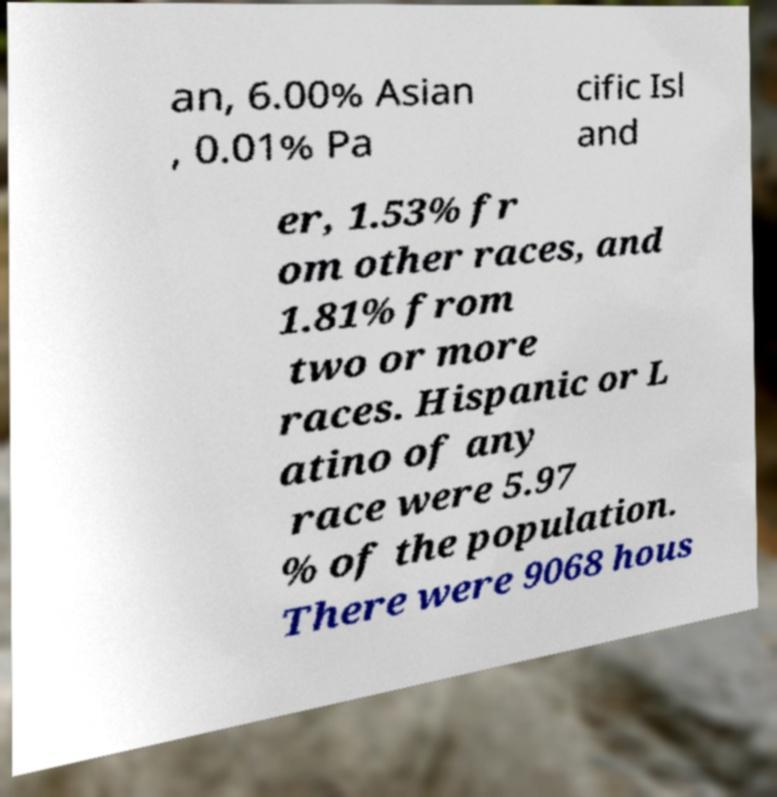I need the written content from this picture converted into text. Can you do that? an, 6.00% Asian , 0.01% Pa cific Isl and er, 1.53% fr om other races, and 1.81% from two or more races. Hispanic or L atino of any race were 5.97 % of the population. There were 9068 hous 